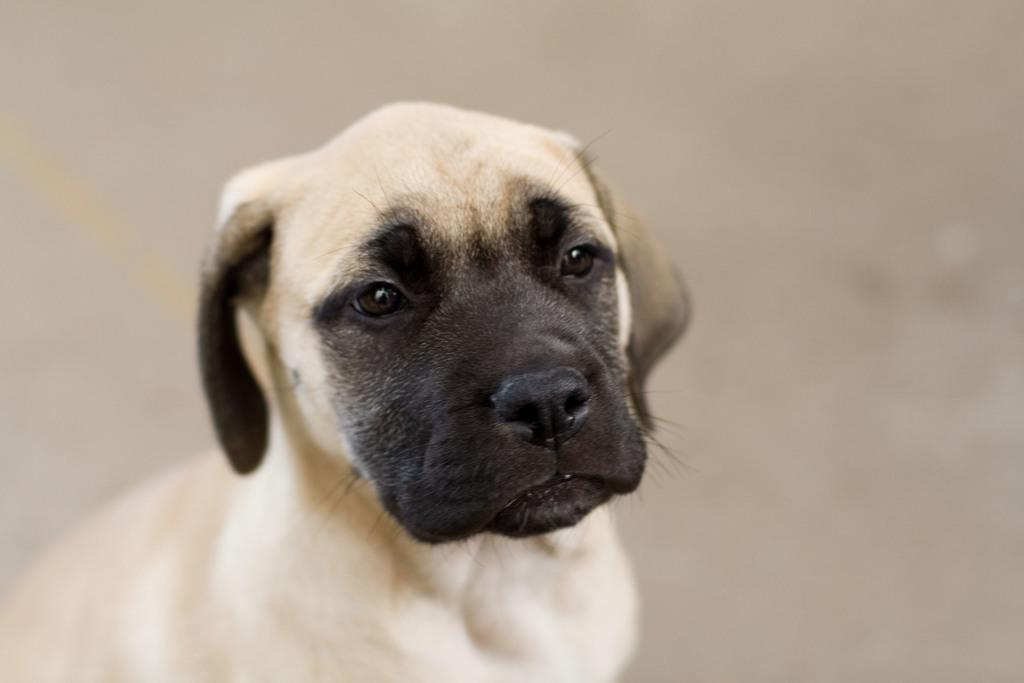What animal is the main subject of the image? There is a dog in the image. Where is the dog positioned in the image? The dog is in the front of the image. Can you describe the background of the image? The background of the image is blurry. What type of zebra can be seen in the background of the image? There is no zebra present in the image; the background is blurry. What historical event is depicted in the image? There is no historical event depicted in the image; it features a dog in the front and a blurry background. 